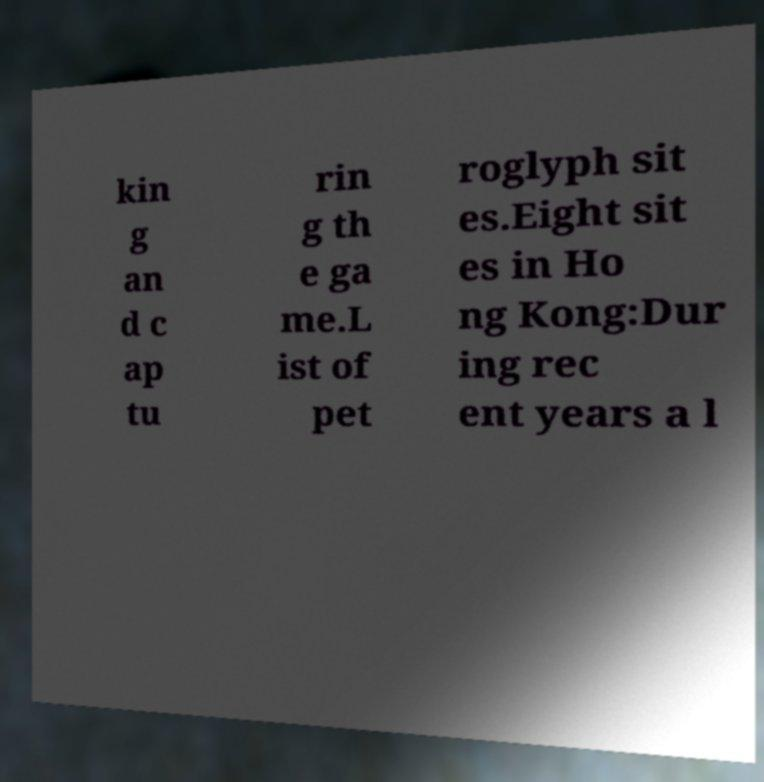Can you accurately transcribe the text from the provided image for me? kin g an d c ap tu rin g th e ga me.L ist of pet roglyph sit es.Eight sit es in Ho ng Kong:Dur ing rec ent years a l 